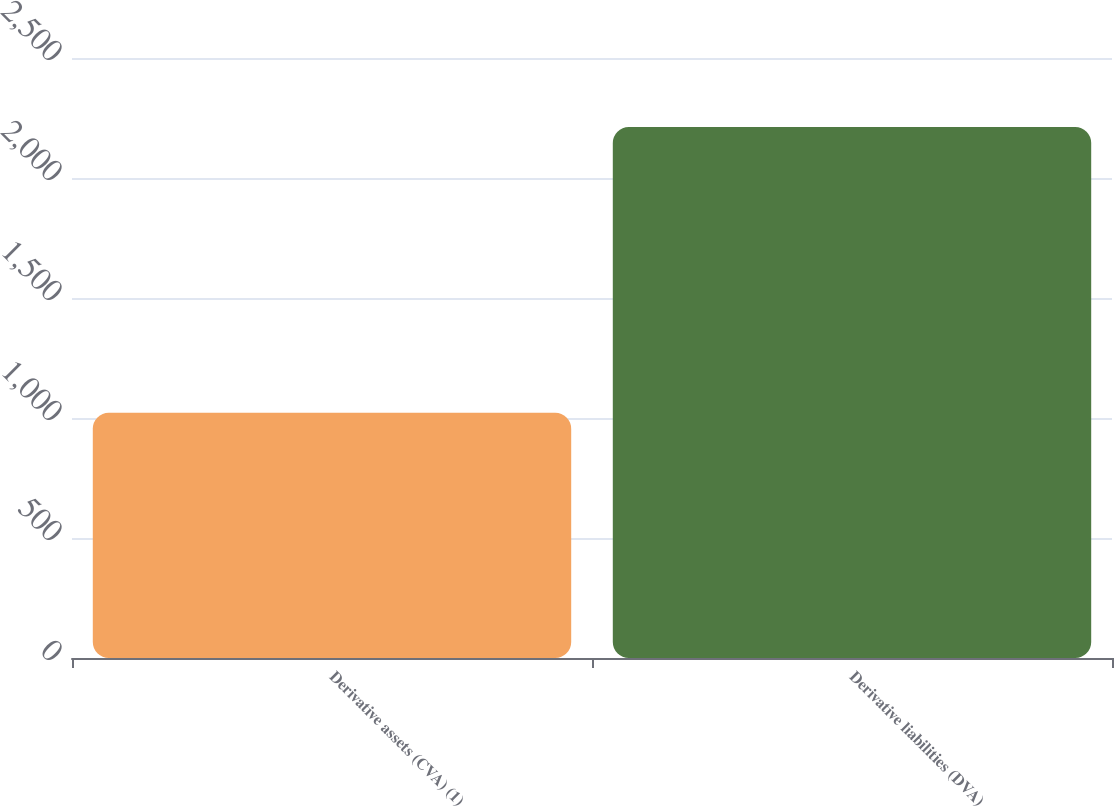Convert chart to OTSL. <chart><loc_0><loc_0><loc_500><loc_500><bar_chart><fcel>Derivative assets (CVA) (1)<fcel>Derivative liabilities (DVA)<nl><fcel>1022<fcel>2212<nl></chart> 